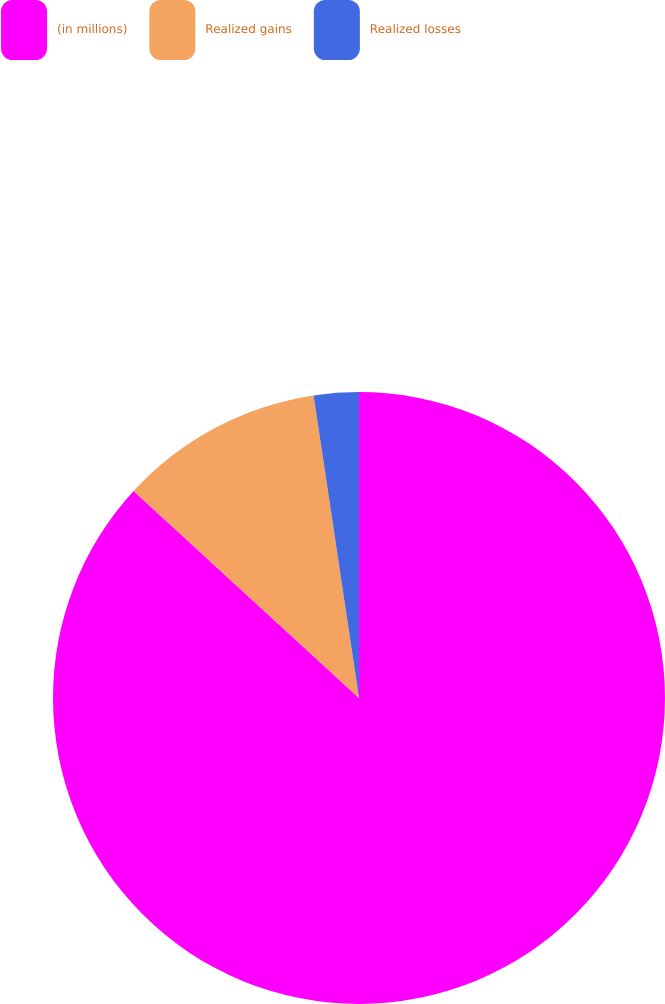Convert chart. <chart><loc_0><loc_0><loc_500><loc_500><pie_chart><fcel>(in millions)<fcel>Realized gains<fcel>Realized losses<nl><fcel>86.82%<fcel>10.81%<fcel>2.37%<nl></chart> 